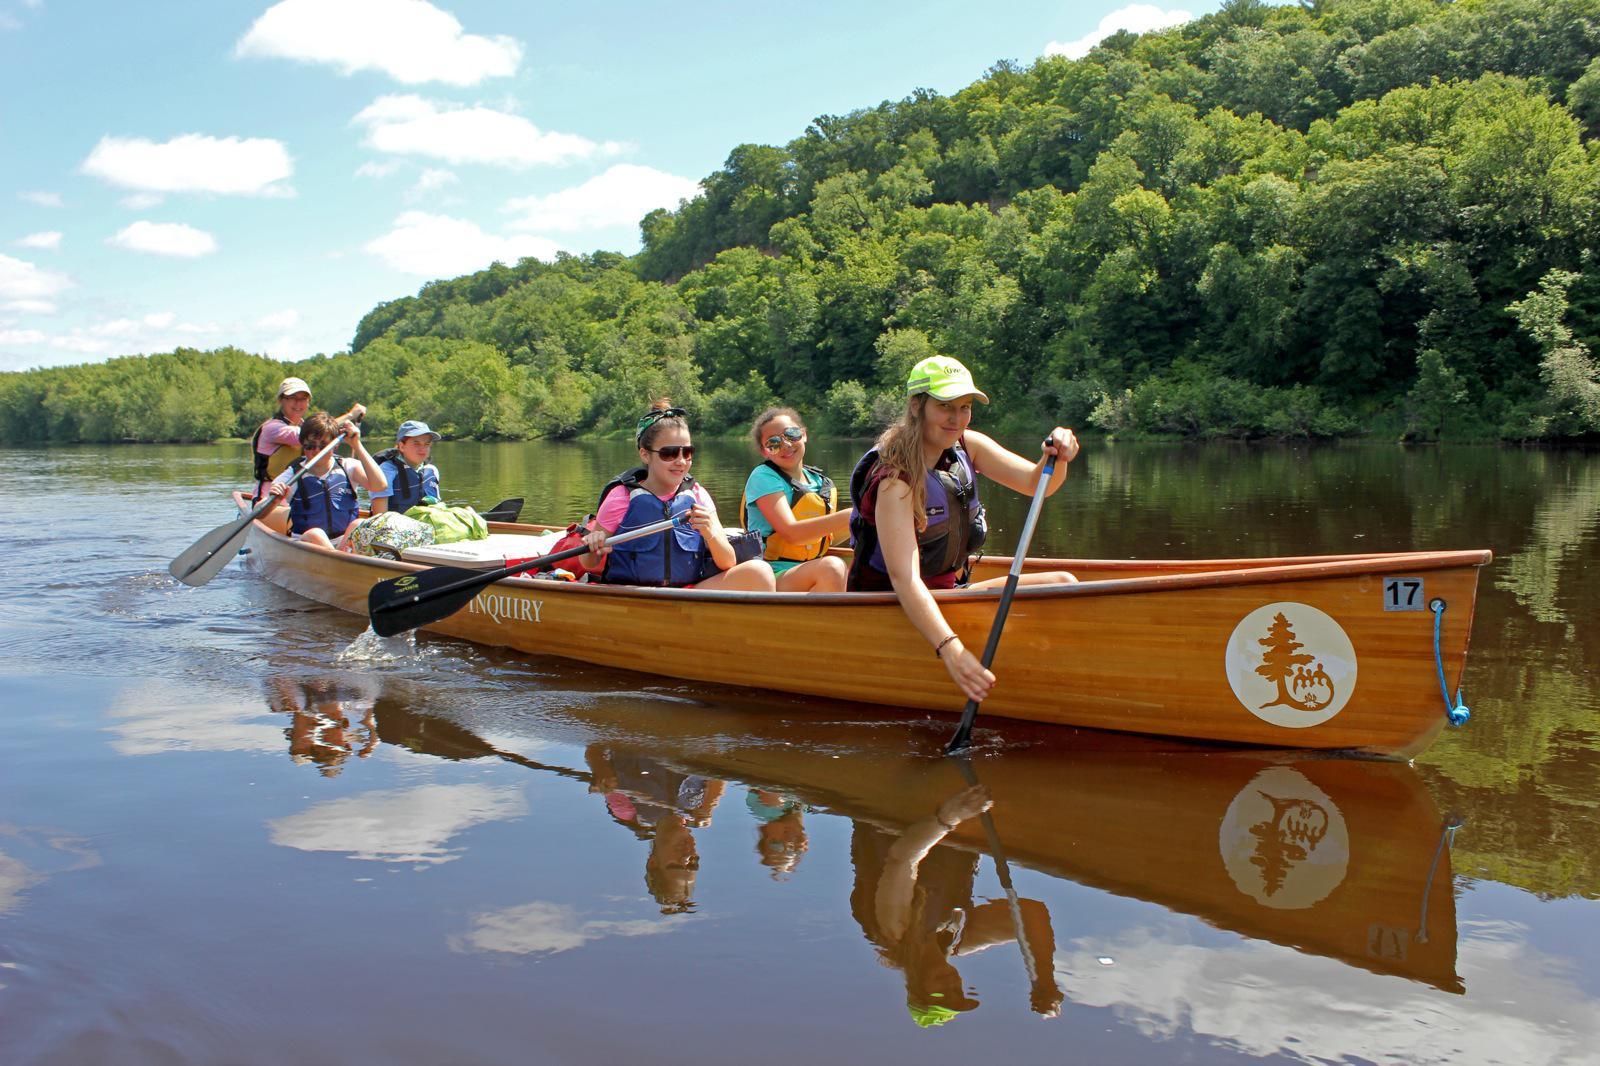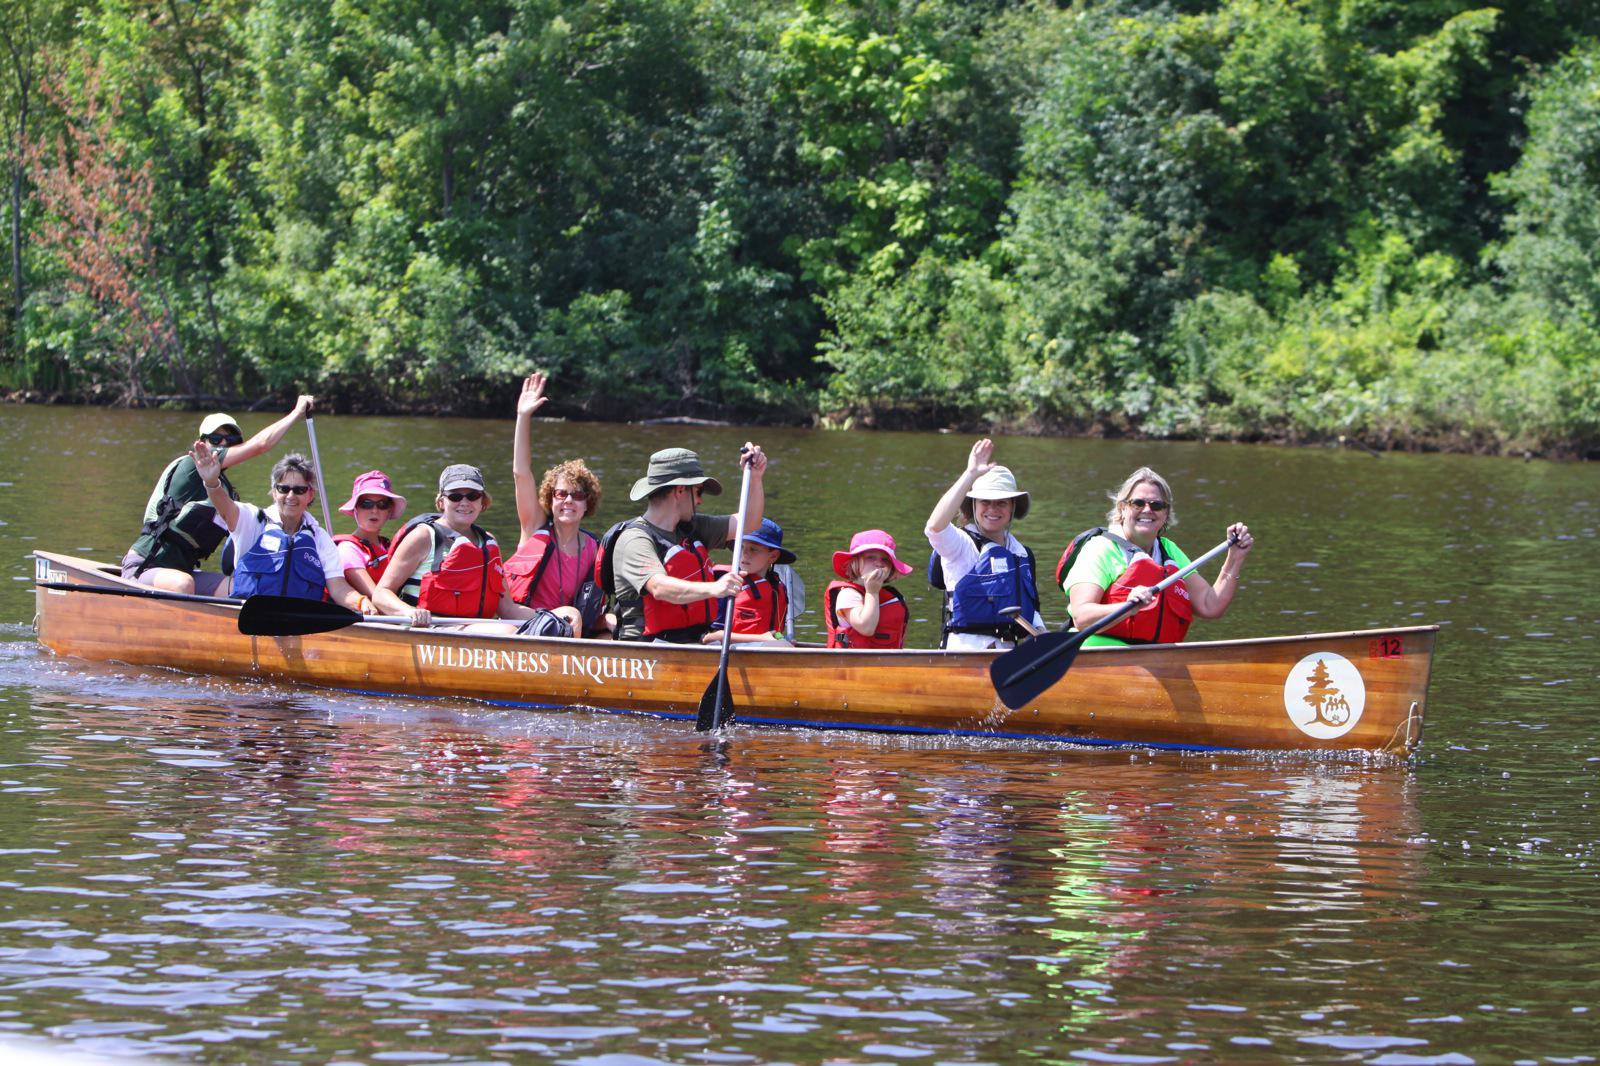The first image is the image on the left, the second image is the image on the right. Assess this claim about the two images: "One image shows exactly one silver canoe with 3 riders.". Correct or not? Answer yes or no. No. The first image is the image on the left, the second image is the image on the right. For the images shown, is this caption "The left photo shows a single silver canoe with three passengers." true? Answer yes or no. No. 